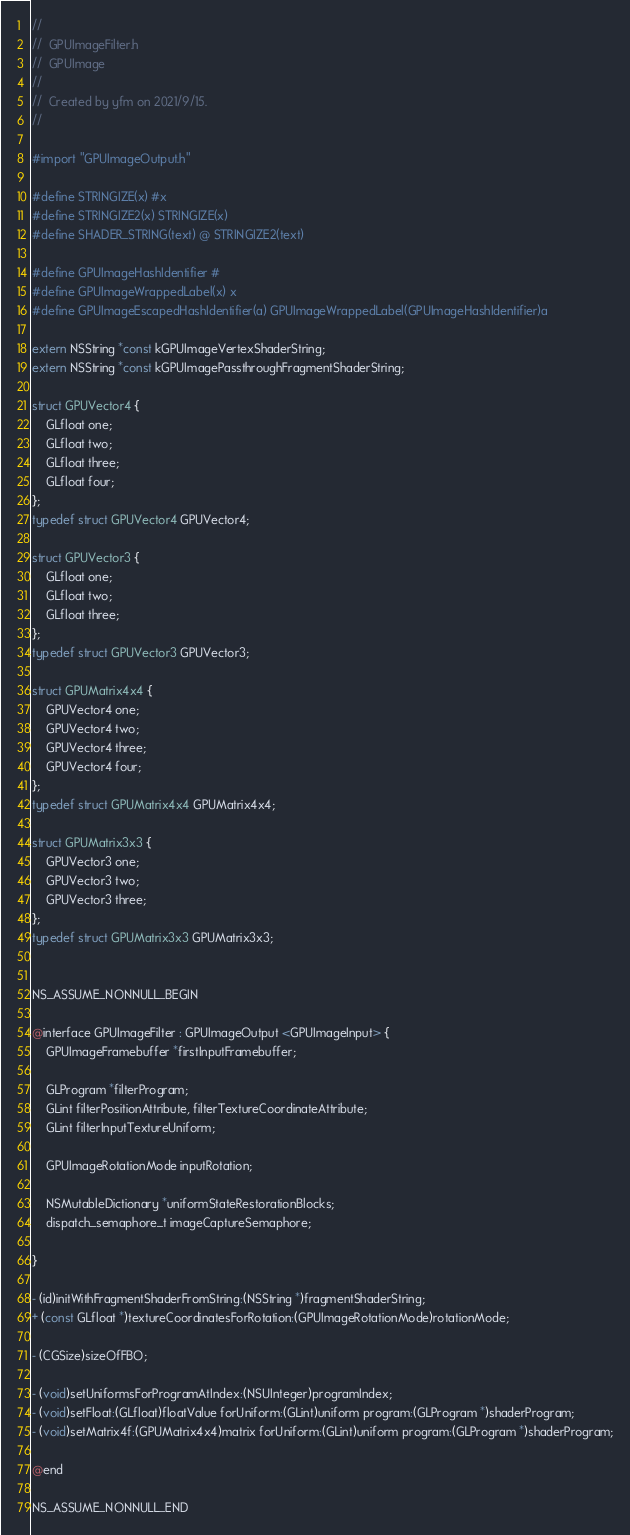<code> <loc_0><loc_0><loc_500><loc_500><_C_>//
//  GPUImageFilter.h
//  GPUImage
//
//  Created by yfm on 2021/9/15.
//

#import "GPUImageOutput.h"

#define STRINGIZE(x) #x
#define STRINGIZE2(x) STRINGIZE(x)
#define SHADER_STRING(text) @ STRINGIZE2(text)

#define GPUImageHashIdentifier #
#define GPUImageWrappedLabel(x) x
#define GPUImageEscapedHashIdentifier(a) GPUImageWrappedLabel(GPUImageHashIdentifier)a

extern NSString *const kGPUImageVertexShaderString;
extern NSString *const kGPUImagePassthroughFragmentShaderString;

struct GPUVector4 {
    GLfloat one;
    GLfloat two;
    GLfloat three;
    GLfloat four;
};
typedef struct GPUVector4 GPUVector4;

struct GPUVector3 {
    GLfloat one;
    GLfloat two;
    GLfloat three;
};
typedef struct GPUVector3 GPUVector3;

struct GPUMatrix4x4 {
    GPUVector4 one;
    GPUVector4 two;
    GPUVector4 three;
    GPUVector4 four;
};
typedef struct GPUMatrix4x4 GPUMatrix4x4;

struct GPUMatrix3x3 {
    GPUVector3 one;
    GPUVector3 two;
    GPUVector3 three;
};
typedef struct GPUMatrix3x3 GPUMatrix3x3;


NS_ASSUME_NONNULL_BEGIN

@interface GPUImageFilter : GPUImageOutput <GPUImageInput> {
    GPUImageFramebuffer *firstInputFramebuffer;
    
    GLProgram *filterProgram;
    GLint filterPositionAttribute, filterTextureCoordinateAttribute;
    GLint filterInputTextureUniform;
    
    GPUImageRotationMode inputRotation;
        
    NSMutableDictionary *uniformStateRestorationBlocks;
    dispatch_semaphore_t imageCaptureSemaphore;

}

- (id)initWithFragmentShaderFromString:(NSString *)fragmentShaderString;
+ (const GLfloat *)textureCoordinatesForRotation:(GPUImageRotationMode)rotationMode;

- (CGSize)sizeOfFBO;

- (void)setUniformsForProgramAtIndex:(NSUInteger)programIndex;
- (void)setFloat:(GLfloat)floatValue forUniform:(GLint)uniform program:(GLProgram *)shaderProgram;
- (void)setMatrix4f:(GPUMatrix4x4)matrix forUniform:(GLint)uniform program:(GLProgram *)shaderProgram;

@end

NS_ASSUME_NONNULL_END
</code> 